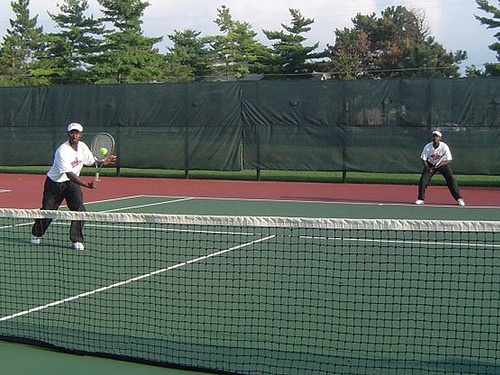Describe the objects in this image and their specific colors. I can see people in white, black, gray, and darkgray tones, people in white, black, gray, and darkgray tones, tennis racket in white and gray tones, tennis racket in white, gray, lightgray, darkgray, and black tones, and sports ball in white, khaki, lightyellow, and olive tones in this image. 